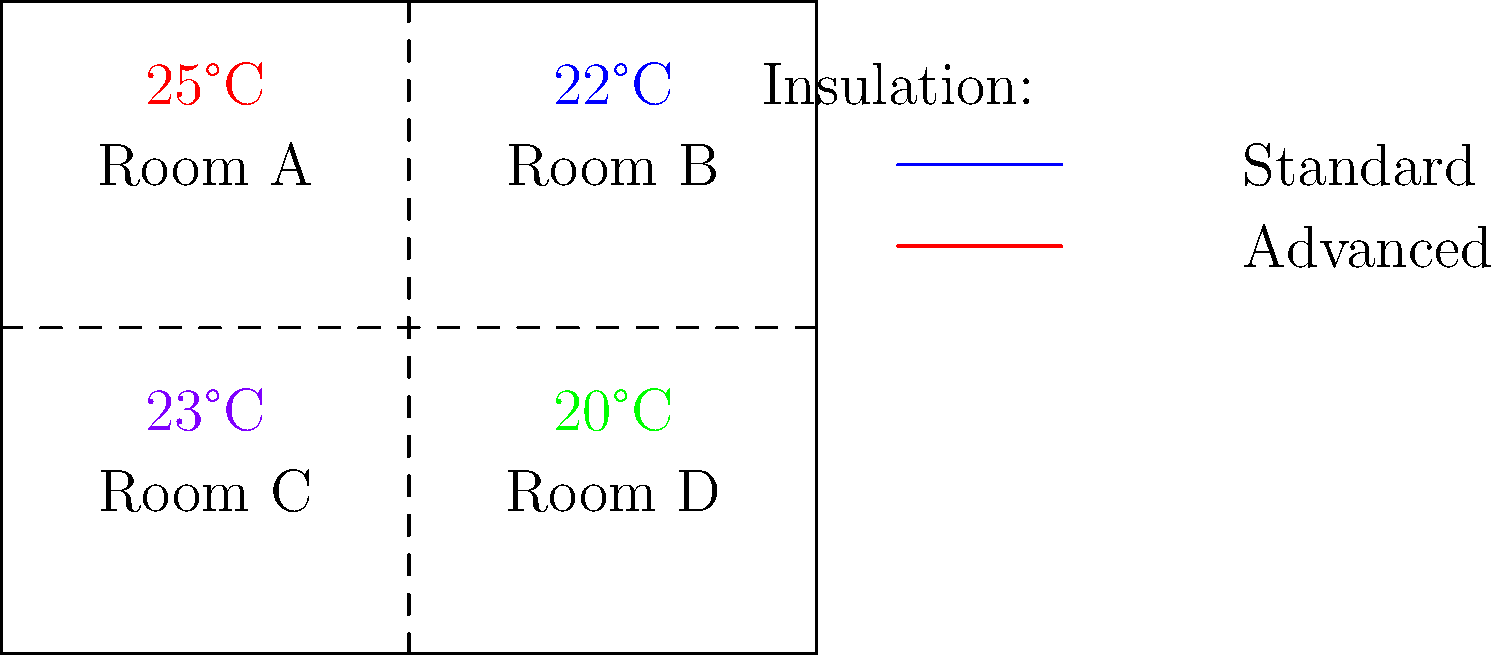An office building has four rooms with different insulation materials. Rooms A and C have advanced insulation, while Rooms B and D have standard insulation. Given the temperature readings shown in the diagram, what is the average temperature difference between the rooms with advanced insulation and those with standard insulation? To solve this problem, we'll follow these steps:

1. Identify the rooms with advanced and standard insulation:
   - Advanced insulation: Rooms A and C
   - Standard insulation: Rooms B and D

2. Calculate the average temperature for rooms with advanced insulation:
   Room A: 25°C
   Room C: 23°C
   Average = $(25°C + 23°C) / 2 = 24°C$

3. Calculate the average temperature for rooms with standard insulation:
   Room B: 22°C
   Room D: 20°C
   Average = $(22°C + 20°C) / 2 = 21°C$

4. Calculate the difference between the two averages:
   Temperature difference = Advanced insulation average - Standard insulation average
   $= 24°C - 21°C = 3°C$

Therefore, the average temperature difference between the rooms with advanced insulation and those with standard insulation is 3°C.
Answer: 3°C 